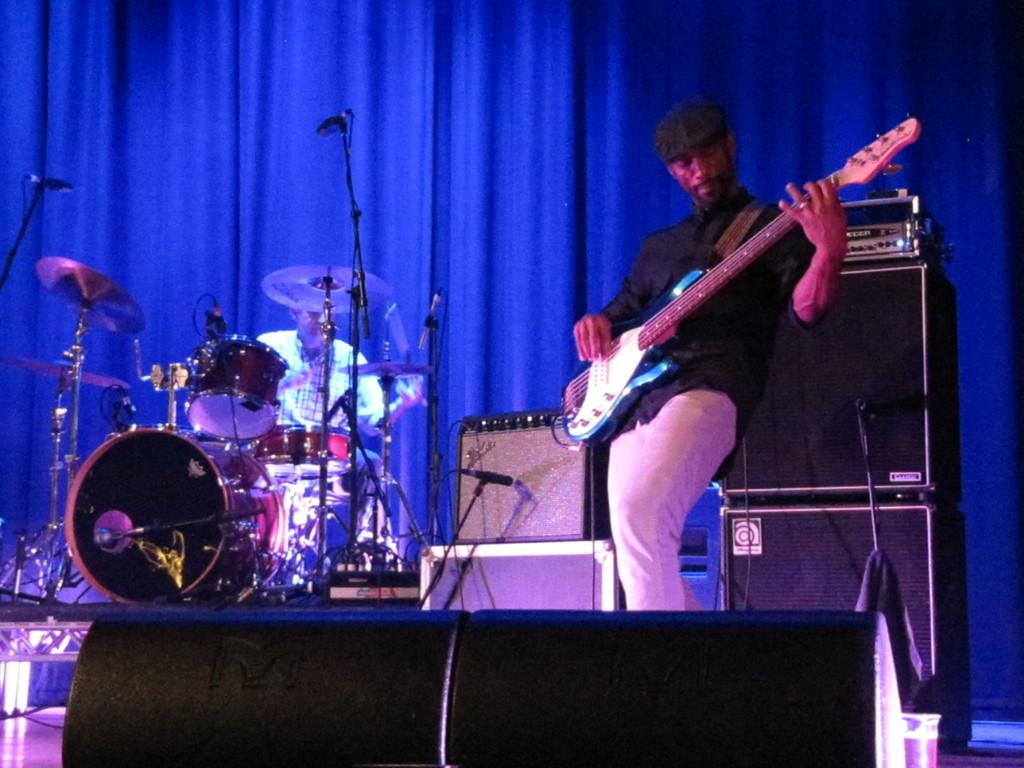What is the man in the image doing? There is a man playing guitar in the image. How is the man holding the guitar? The man is holding the guitar in the image. Are there any other musicians in the image? Yes, there is a man seated and playing drums in the image. What type of fowl can be seen eating a meal in the image? There is no fowl or meal present in the image; it features two musicians playing instruments. 